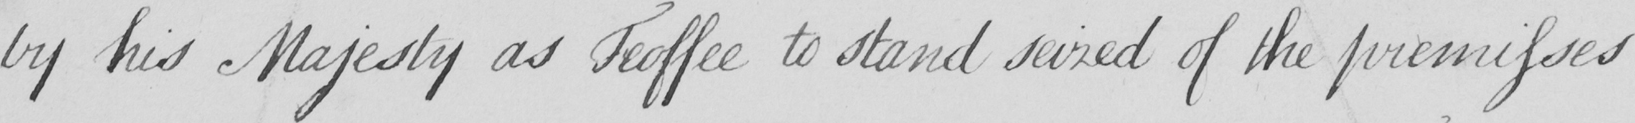What is written in this line of handwriting? by his Majesty as Feoffee to stand seized of the premisses 